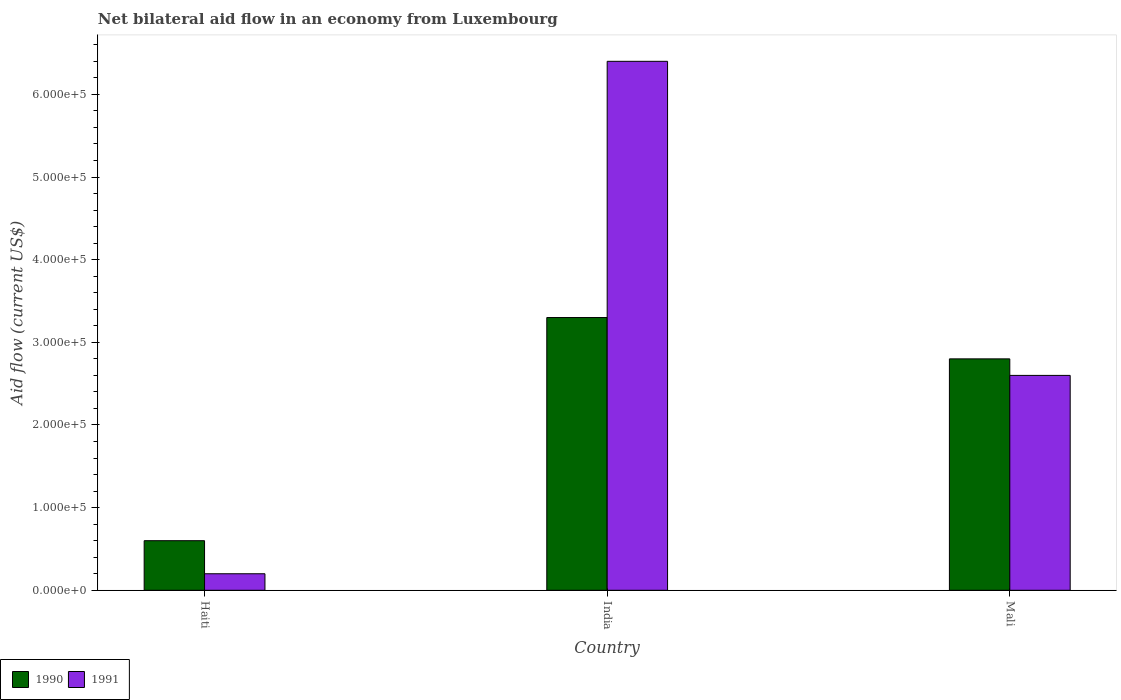How many different coloured bars are there?
Your response must be concise. 2. How many groups of bars are there?
Give a very brief answer. 3. Are the number of bars per tick equal to the number of legend labels?
Ensure brevity in your answer.  Yes. Are the number of bars on each tick of the X-axis equal?
Provide a succinct answer. Yes. What is the label of the 1st group of bars from the left?
Ensure brevity in your answer.  Haiti. Across all countries, what is the maximum net bilateral aid flow in 1990?
Your response must be concise. 3.30e+05. Across all countries, what is the minimum net bilateral aid flow in 1991?
Provide a short and direct response. 2.00e+04. In which country was the net bilateral aid flow in 1991 minimum?
Your answer should be very brief. Haiti. What is the total net bilateral aid flow in 1990 in the graph?
Offer a very short reply. 6.70e+05. What is the difference between the net bilateral aid flow in 1991 in Haiti and that in India?
Offer a very short reply. -6.20e+05. What is the difference between the net bilateral aid flow in 1990 in India and the net bilateral aid flow in 1991 in Haiti?
Provide a short and direct response. 3.10e+05. What is the average net bilateral aid flow in 1990 per country?
Your answer should be compact. 2.23e+05. What is the difference between the net bilateral aid flow of/in 1990 and net bilateral aid flow of/in 1991 in India?
Give a very brief answer. -3.10e+05. What is the ratio of the net bilateral aid flow in 1991 in India to that in Mali?
Provide a succinct answer. 2.46. Is the difference between the net bilateral aid flow in 1990 in India and Mali greater than the difference between the net bilateral aid flow in 1991 in India and Mali?
Your response must be concise. No. What is the difference between the highest and the second highest net bilateral aid flow in 1991?
Give a very brief answer. 6.20e+05. What is the difference between the highest and the lowest net bilateral aid flow in 1991?
Offer a very short reply. 6.20e+05. Is the sum of the net bilateral aid flow in 1991 in India and Mali greater than the maximum net bilateral aid flow in 1990 across all countries?
Provide a succinct answer. Yes. What does the 2nd bar from the right in Haiti represents?
Your response must be concise. 1990. How many bars are there?
Provide a short and direct response. 6. What is the difference between two consecutive major ticks on the Y-axis?
Ensure brevity in your answer.  1.00e+05. Are the values on the major ticks of Y-axis written in scientific E-notation?
Your response must be concise. Yes. How are the legend labels stacked?
Make the answer very short. Horizontal. What is the title of the graph?
Make the answer very short. Net bilateral aid flow in an economy from Luxembourg. What is the label or title of the X-axis?
Ensure brevity in your answer.  Country. What is the label or title of the Y-axis?
Make the answer very short. Aid flow (current US$). What is the Aid flow (current US$) of 1991 in Haiti?
Give a very brief answer. 2.00e+04. What is the Aid flow (current US$) of 1991 in India?
Provide a short and direct response. 6.40e+05. What is the Aid flow (current US$) of 1990 in Mali?
Provide a succinct answer. 2.80e+05. What is the Aid flow (current US$) of 1991 in Mali?
Your answer should be very brief. 2.60e+05. Across all countries, what is the maximum Aid flow (current US$) in 1991?
Offer a terse response. 6.40e+05. Across all countries, what is the minimum Aid flow (current US$) in 1991?
Provide a short and direct response. 2.00e+04. What is the total Aid flow (current US$) of 1990 in the graph?
Your answer should be very brief. 6.70e+05. What is the total Aid flow (current US$) in 1991 in the graph?
Ensure brevity in your answer.  9.20e+05. What is the difference between the Aid flow (current US$) in 1990 in Haiti and that in India?
Your answer should be very brief. -2.70e+05. What is the difference between the Aid flow (current US$) in 1991 in Haiti and that in India?
Provide a short and direct response. -6.20e+05. What is the difference between the Aid flow (current US$) of 1990 in Haiti and that in Mali?
Give a very brief answer. -2.20e+05. What is the difference between the Aid flow (current US$) in 1991 in Haiti and that in Mali?
Your answer should be very brief. -2.40e+05. What is the difference between the Aid flow (current US$) of 1990 in India and that in Mali?
Your response must be concise. 5.00e+04. What is the difference between the Aid flow (current US$) in 1990 in Haiti and the Aid flow (current US$) in 1991 in India?
Keep it short and to the point. -5.80e+05. What is the difference between the Aid flow (current US$) of 1990 in Haiti and the Aid flow (current US$) of 1991 in Mali?
Your answer should be compact. -2.00e+05. What is the average Aid flow (current US$) of 1990 per country?
Keep it short and to the point. 2.23e+05. What is the average Aid flow (current US$) of 1991 per country?
Offer a very short reply. 3.07e+05. What is the difference between the Aid flow (current US$) in 1990 and Aid flow (current US$) in 1991 in India?
Offer a terse response. -3.10e+05. What is the ratio of the Aid flow (current US$) in 1990 in Haiti to that in India?
Give a very brief answer. 0.18. What is the ratio of the Aid flow (current US$) in 1991 in Haiti to that in India?
Offer a very short reply. 0.03. What is the ratio of the Aid flow (current US$) in 1990 in Haiti to that in Mali?
Ensure brevity in your answer.  0.21. What is the ratio of the Aid flow (current US$) in 1991 in Haiti to that in Mali?
Provide a succinct answer. 0.08. What is the ratio of the Aid flow (current US$) in 1990 in India to that in Mali?
Provide a succinct answer. 1.18. What is the ratio of the Aid flow (current US$) of 1991 in India to that in Mali?
Offer a terse response. 2.46. What is the difference between the highest and the second highest Aid flow (current US$) in 1990?
Ensure brevity in your answer.  5.00e+04. What is the difference between the highest and the lowest Aid flow (current US$) in 1990?
Provide a short and direct response. 2.70e+05. What is the difference between the highest and the lowest Aid flow (current US$) in 1991?
Your response must be concise. 6.20e+05. 